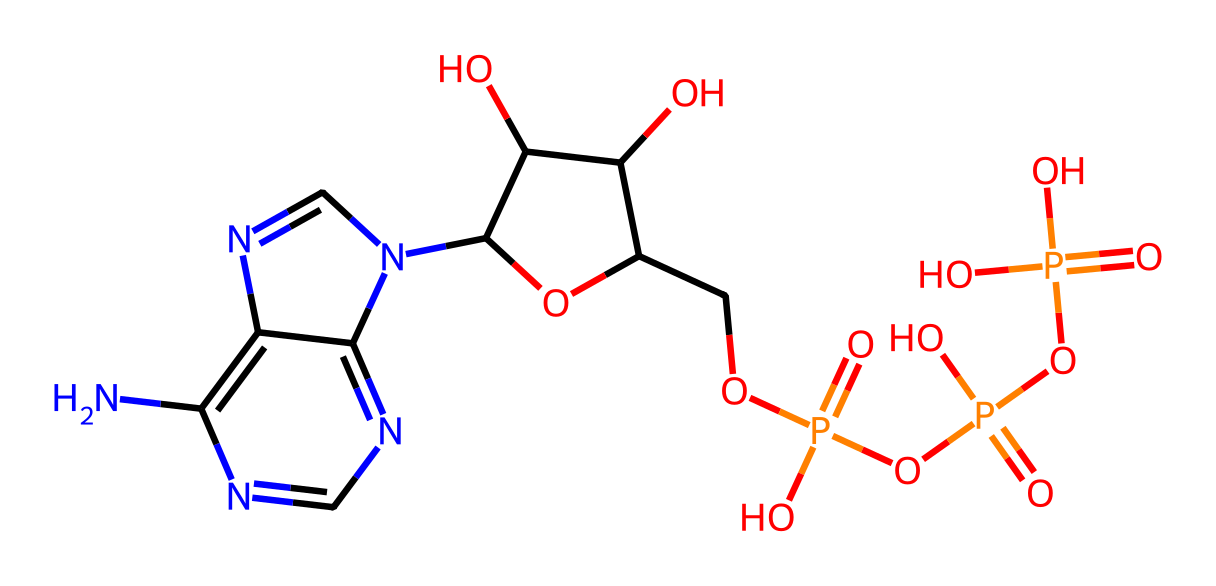What is the overall charge of ATP? To determine the overall charge, we must consider the phosphate groups attached to ATP. Each phosphate group is negatively charged. ATP contains four phosphate groups in total (three in the triphosphate and one hydrolyzed in the structure). Therefore, the overall charge is negative.
Answer: negative How many nitrogen atoms are present in ATP? By examining the SMILES representation, we can identify the nitrogen atoms. There are five nitrogen atoms within the structure. Counting them directly in the SMILES confirms this.
Answer: five What type of bond connects the phosphate groups in ATP? ATP contains phosphoanhydride bonds connecting the phosphate groups. These bonds are crucial for energy transfer. The presence of any modified backbone highlighted in the SMILES indicates their connection type.
Answer: phosphoanhydride Identify the type of sugar in ATP. The structure depicts ribose as the sugar component because of the hydroxyl (-OH) groups on the second and third carbons, characteristic of ribose. This can be identified from the structure conformity of the ribose sugar represented in the SMILES.
Answer: ribose What is the role of ATP in biological systems? ATP serves as a primary energy currency in cells, facilitating various biochemical reactions. This is due to the high energy released upon hydrolysis of its phosphate groups, an essential role highlighted in biochemical pathways.
Answer: energy currency How many total carbon atoms are in ATP? By illuminating the structure, there are 10 carbon atoms present in the ATP molecule when counted directly from the SMILES representation. The total accounts for those in the sugar and base.
Answer: ten 